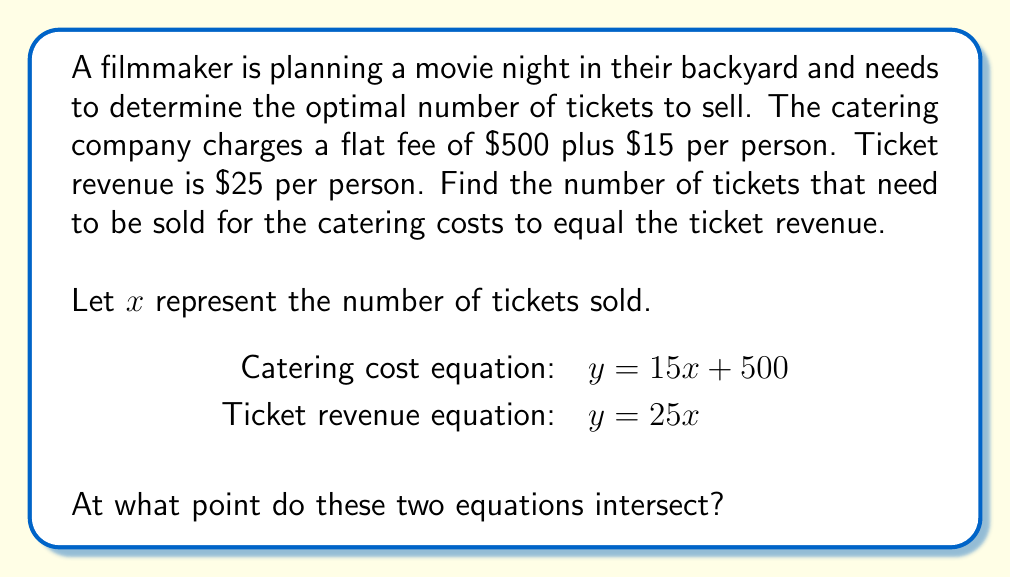What is the answer to this math problem? To find the intersection point of the two linear equations, we need to solve them simultaneously:

1) Set the equations equal to each other:
   $15x + 500 = 25x$

2) Subtract $15x$ from both sides:
   $500 = 10x$

3) Divide both sides by 10:
   $50 = x$

4) To find the y-coordinate, substitute $x = 50$ into either equation:
   $y = 25(50) = 1250$

Therefore, the intersection point is (50, 1250).

This means that when 50 tickets are sold, both the catering costs and ticket revenue will be $1250.
Answer: (50, 1250) 